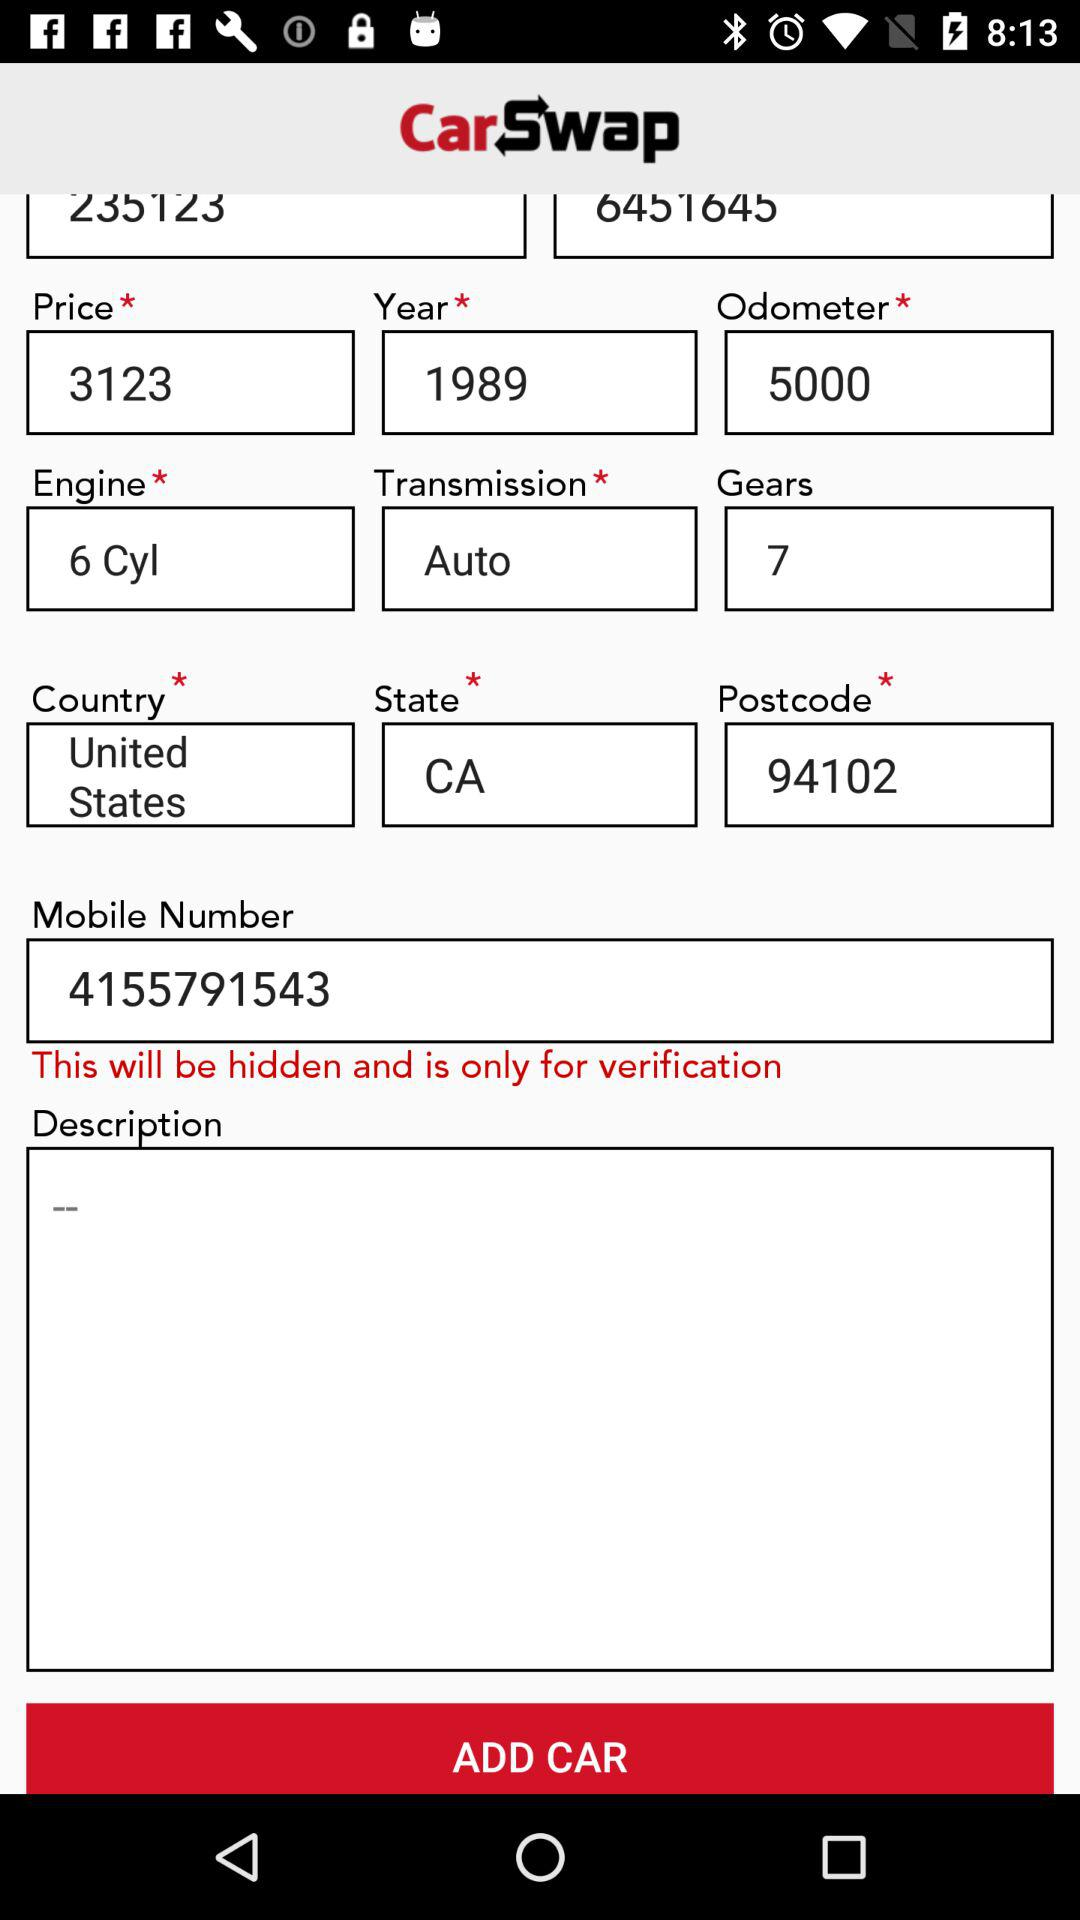What is the price of the car in "CarSwap"? The price of the car in "CarSwap" is 3123. 